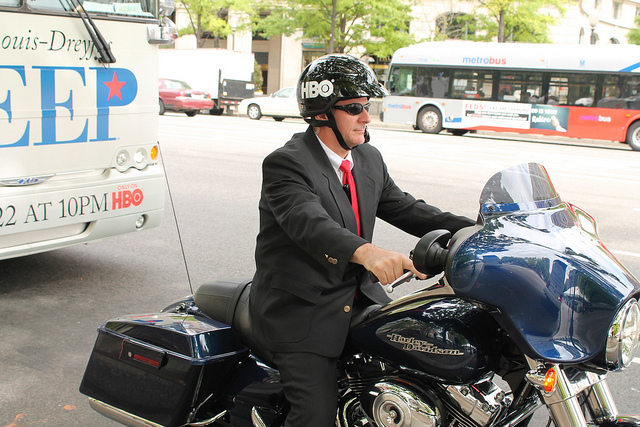Please extract the text content from this image. metrobus HBO AT 10PM HBO Harley EEP 22 ouis- -Dreyfes 